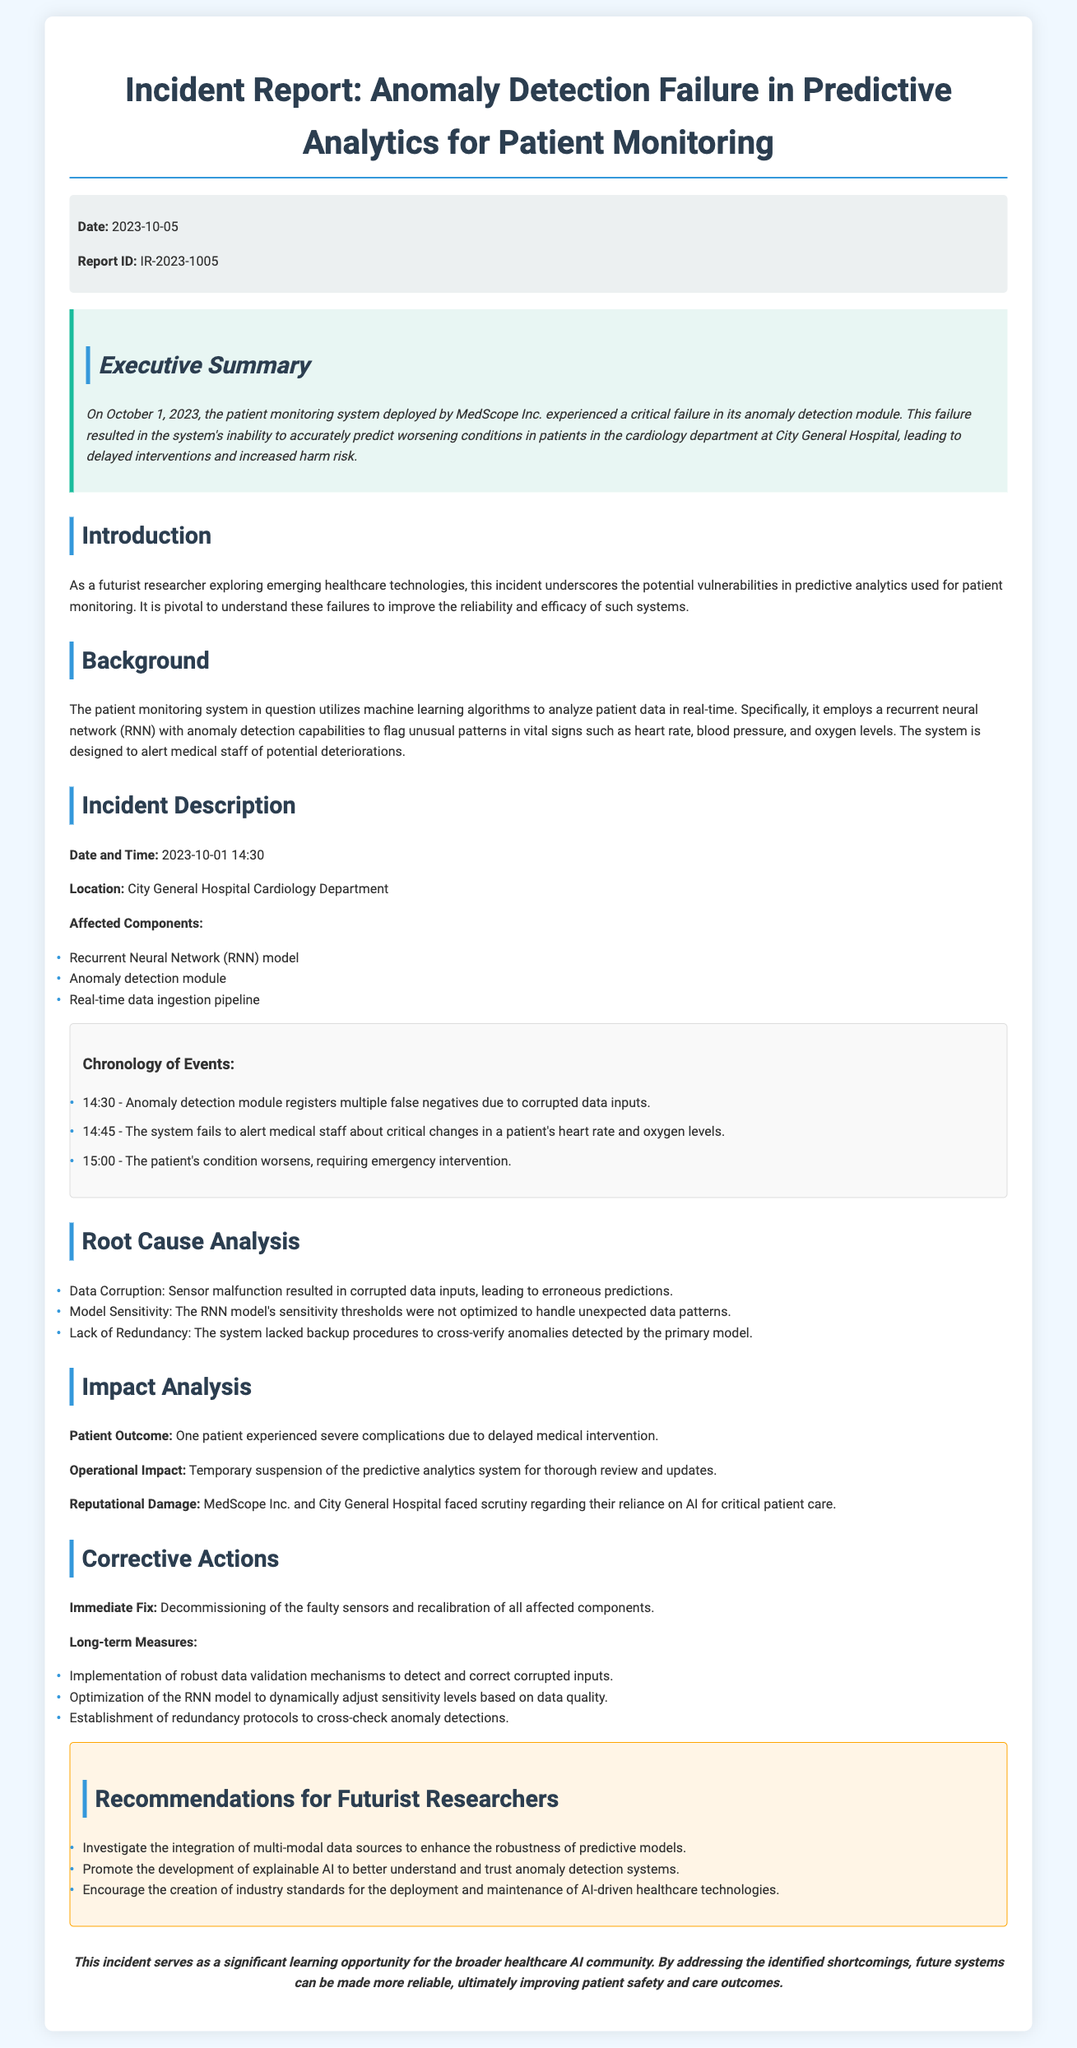what was the date of the incident? The date of the incident is provided in the document, specifically noted in the executive summary and incident description.
Answer: October 1, 2023 what was the report ID? The report ID is explicitly stated in the meta-info section of the document.
Answer: IR-2023-1005 where did the incident occur? The location of the incident is mentioned in the incident description section of the document.
Answer: City General Hospital Cardiology Department what was one of the root causes of the failure? The document lists multiple root causes under the root cause analysis section, providing a clear reason for the anomaly detection failure.
Answer: Data Corruption what time did the anomaly detection module register false negatives? The document details the specific time in the chronology of events, pinpointing when the issue began.
Answer: 14:30 what immediate fix was applied? The incident report mentions the immediate action taken to address the issue right after the incident occurred.
Answer: Decommissioning of the faulty sensors what is a recommended long-term measure? The recommendations section of the document outlines several long-term measures to improve system reliability after the incident.
Answer: Implementation of robust data validation mechanisms how many patients were affected by this incident? The impact analysis section notes the specific outcomes for patients affected by the anomaly detection failure.
Answer: One patient what type of model was used in the patient monitoring system? The background section of the document specifies the type of machine learning model utilized in the predictive analytics framework.
Answer: Recurrent neural network (RNN) 